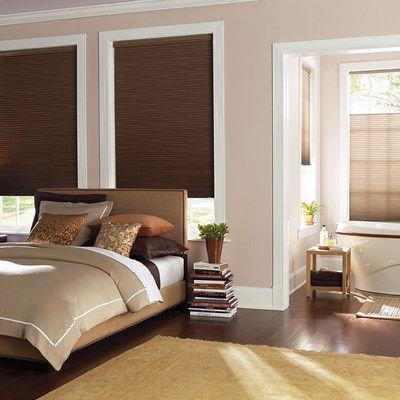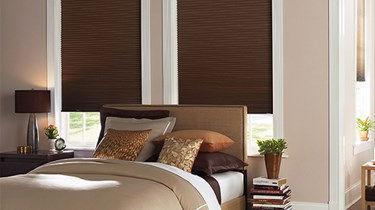The first image is the image on the left, the second image is the image on the right. Assess this claim about the two images: "One image shows the headboard of a bed in front of two windows with solid-colored shades, and a table lamp is nearby on a dresser.". Correct or not? Answer yes or no. Yes. The first image is the image on the left, the second image is the image on the right. Considering the images on both sides, is "There is a total of four blinds." valid? Answer yes or no. No. 